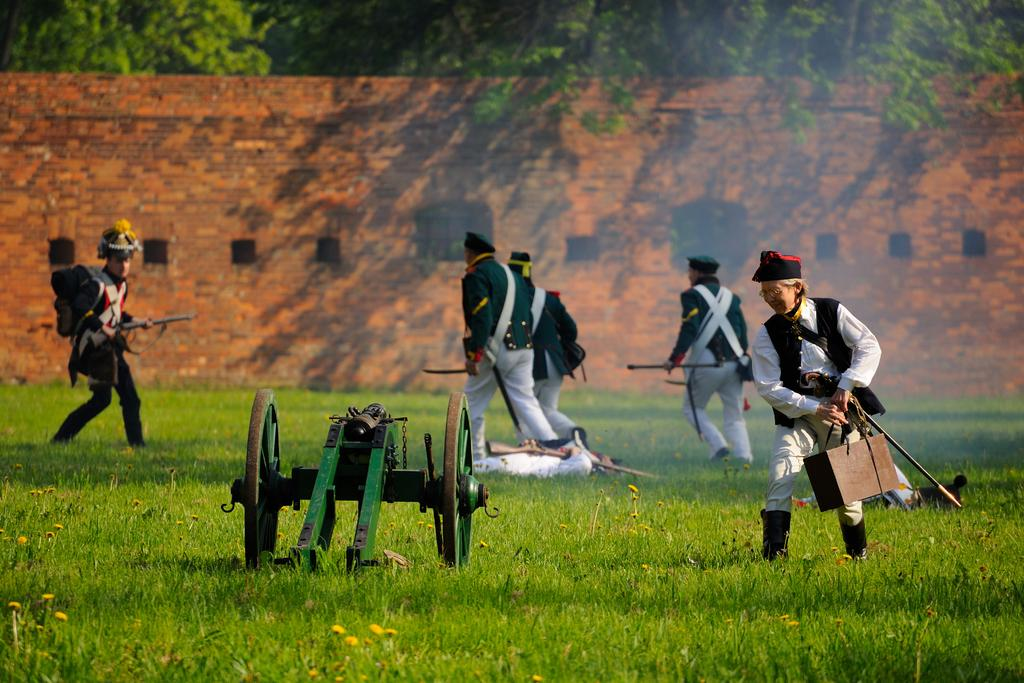How many people are in the image? There is a group of persons in the image. What are the persons in the image doing? The persons are standing and holding guns. What object can be seen on the ground in the image? There is a cannon on the ground. What is visible in the background of the image? There is a wall and trees present at the back of the image. How many legs does the sail have in the image? There is no sail present in the image, so it is not possible to determine the number of legs it might have. 